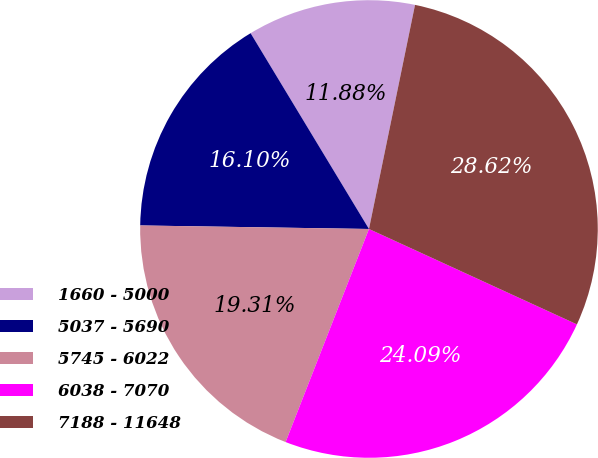<chart> <loc_0><loc_0><loc_500><loc_500><pie_chart><fcel>1660 - 5000<fcel>5037 - 5690<fcel>5745 - 6022<fcel>6038 - 7070<fcel>7188 - 11648<nl><fcel>11.88%<fcel>16.1%<fcel>19.31%<fcel>24.09%<fcel>28.62%<nl></chart> 